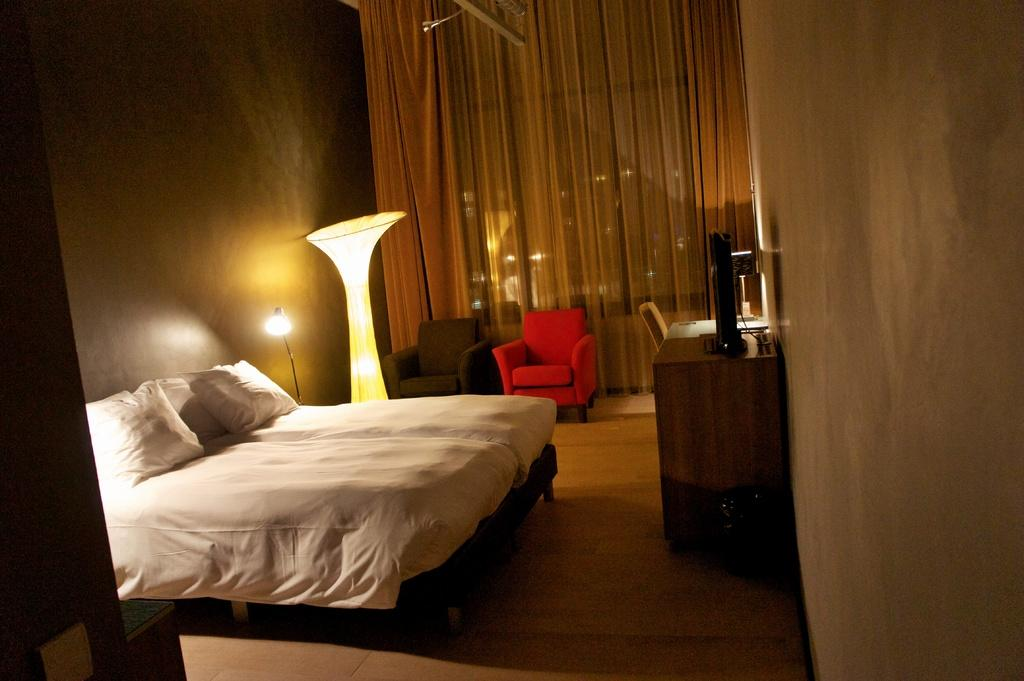What type of furniture is present on the bed in the image? There are pillows on a bed in the image. What type of lighting is present in the image? There are lamps in the image. What type of seating is present in the image? There are sofas in the image. What type of surface can be seen in the foreground of the image? There are objects on a desk in the foreground area of the image. What type of window treatment is present in the background of the image? There are curtains in the background of the image. What type of pest can be seen crawling on the pillows in the image? There are no pests present in the image; it only features pillows on a bed. Is there a bathtub visible in the image? There is no bathtub present in the image. 